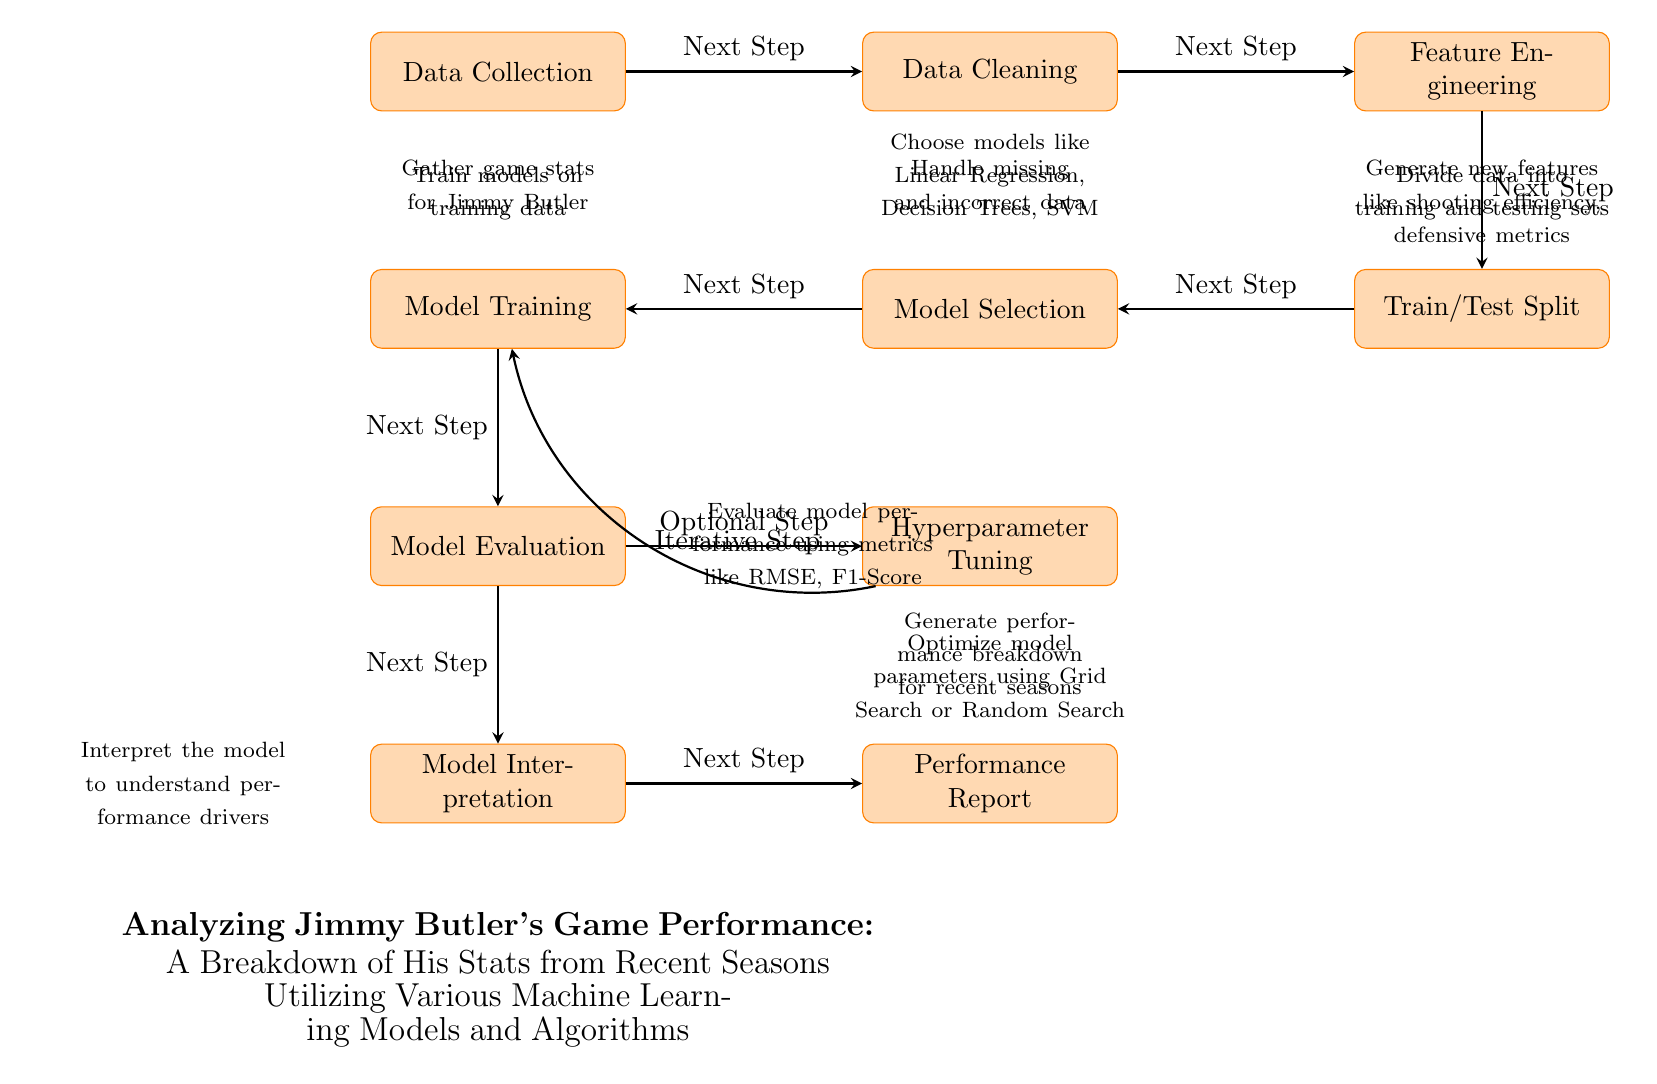What is the first step in the diagram? The first step in the diagram is labeled "Data Collection," which is the initial process in analyzing Jimmy Butler's game performance. It indicates gathering relevant game stats for analysis.
Answer: Data Collection How many processes are shown in the diagram? The diagram features a total of 10 distinct processes that outline the machine learning workflow for analyzing player performance.
Answer: 10 Which node comes after "Feature Engineering"? The node that follows "Feature Engineering" is "Train/Test Split," indicating that after generating features, the data is divided into training and testing sets for model training.
Answer: Train/Test Split What is the relationship between "Model Evaluation" and "Hyperparameter Tuning"? The relationship between "Model Evaluation" and "Hyperparameter Tuning" is indicated by an optional step arrow pointing from "Model Evaluation" to "Hyperparameter Tuning," suggesting that after evaluating the model, one can optionally tune hyperparameters to improve performance.
Answer: Optional Step What does "Model Interpretation" aim to achieve? "Model Interpretation" aims to understand the drivers behind the model's performance by analyzing how different features impact predictions, which is critical for making informed conclusions about Jimmy Butler's game stats.
Answer: Understand performance drivers What is the purpose of the "Performance Report" node? The purpose of the "Performance Report" node is to generate a breakdown of performance metrics for Jimmy Butler's recent seasons, summarizing the insights gained from the analysis and model predictions.
Answer: Generate performance breakdown What iterative step is indicated in the diagram? The iterative step in the diagram is represented by the arrow from "Hyperparameter Tuning" back to "Model Training," indicating that after tuning, one might need to retrain the model to see the improvements from the optimized parameters.
Answer: Iterative Step Which nodes indicate data management? The nodes that indicate data management in the diagram are "Data Collection," "Data Cleaning," and "Feature Engineering," as they collectively involve gathering, preparing, and enhancing the data for analysis and model training.
Answer: Data Collection, Data Cleaning, Feature Engineering What type of models might be selected during "Model Selection"? During "Model Selection," models like Linear Regression, Decision Trees, and Support Vector Machines (SVM) might be considered for analyzing Jimmy Butler's game stats based on their performance characteristics.
Answer: Linear Regression, Decision Trees, SVM 